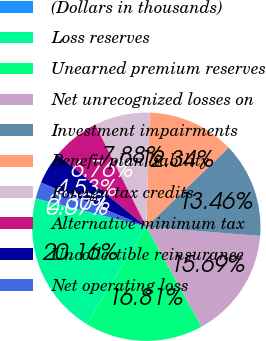<chart> <loc_0><loc_0><loc_500><loc_500><pie_chart><fcel>(Dollars in thousands)<fcel>Loss reserves<fcel>Unearned premium reserves<fcel>Net unrecognized losses on<fcel>Investment impairments<fcel>Benefit plan liability<fcel>Foreign tax credits<fcel>Alternative minimum tax<fcel>Uncollectible reinsurance<fcel>Net operating loss<nl><fcel>0.07%<fcel>20.16%<fcel>16.81%<fcel>15.69%<fcel>13.46%<fcel>12.34%<fcel>7.88%<fcel>6.76%<fcel>4.53%<fcel>2.3%<nl></chart> 